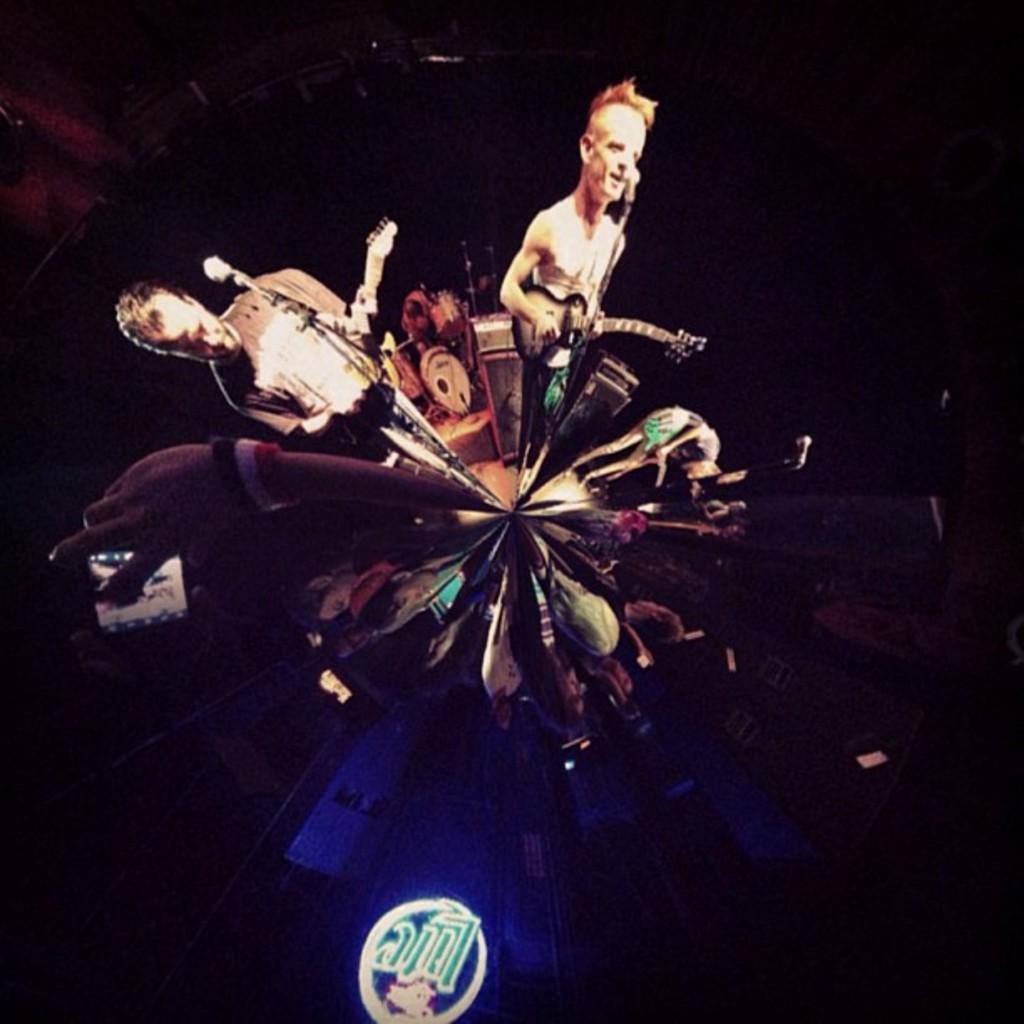Describe this image in one or two sentences. In the image we can see there are people wearing clothes and holding a guitar in the hands. This is a microphone and musical instruments. This is a symbol. 